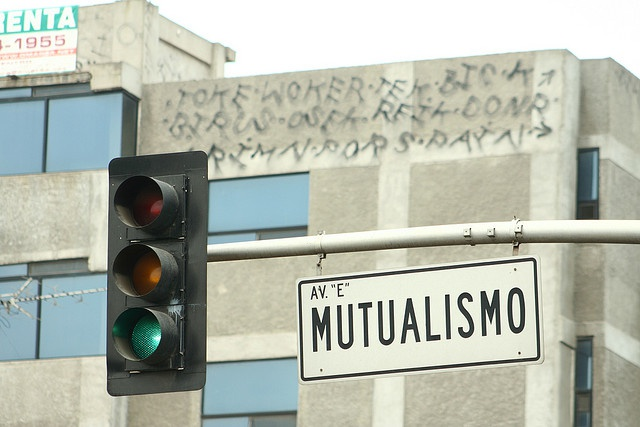Describe the objects in this image and their specific colors. I can see a traffic light in white, black, and gray tones in this image. 